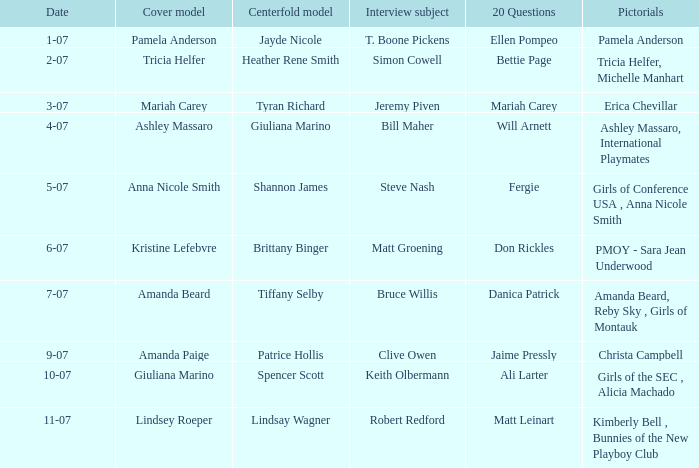Give me the full table as a dictionary. {'header': ['Date', 'Cover model', 'Centerfold model', 'Interview subject', '20 Questions', 'Pictorials'], 'rows': [['1-07', 'Pamela Anderson', 'Jayde Nicole', 'T. Boone Pickens', 'Ellen Pompeo', 'Pamela Anderson'], ['2-07', 'Tricia Helfer', 'Heather Rene Smith', 'Simon Cowell', 'Bettie Page', 'Tricia Helfer, Michelle Manhart'], ['3-07', 'Mariah Carey', 'Tyran Richard', 'Jeremy Piven', 'Mariah Carey', 'Erica Chevillar'], ['4-07', 'Ashley Massaro', 'Giuliana Marino', 'Bill Maher', 'Will Arnett', 'Ashley Massaro, International Playmates'], ['5-07', 'Anna Nicole Smith', 'Shannon James', 'Steve Nash', 'Fergie', 'Girls of Conference USA , Anna Nicole Smith'], ['6-07', 'Kristine Lefebvre', 'Brittany Binger', 'Matt Groening', 'Don Rickles', 'PMOY - Sara Jean Underwood'], ['7-07', 'Amanda Beard', 'Tiffany Selby', 'Bruce Willis', 'Danica Patrick', 'Amanda Beard, Reby Sky , Girls of Montauk'], ['9-07', 'Amanda Paige', 'Patrice Hollis', 'Clive Owen', 'Jaime Pressly', 'Christa Campbell'], ['10-07', 'Giuliana Marino', 'Spencer Scott', 'Keith Olbermann', 'Ali Larter', 'Girls of the SEC , Alicia Machado'], ['11-07', 'Lindsey Roeper', 'Lindsay Wagner', 'Robert Redford', 'Matt Leinart', 'Kimberly Bell , Bunnies of the New Playboy Club']]} Who provided answers to the 20 questions on october 7th? Ali Larter. 